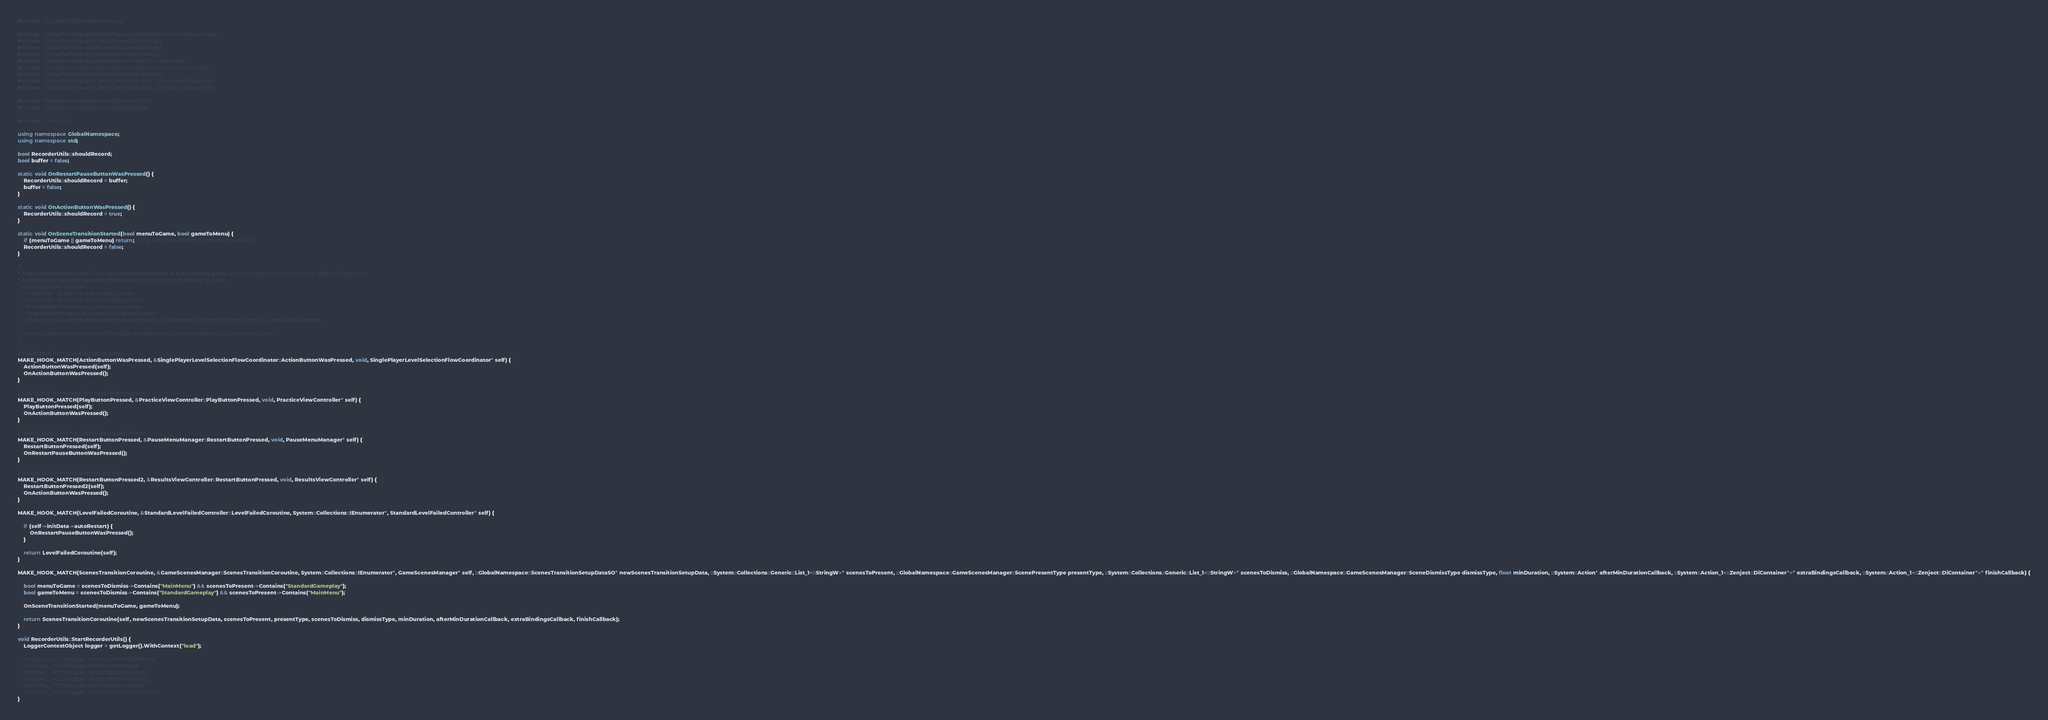Convert code to text. <code><loc_0><loc_0><loc_500><loc_500><_C++_>
#include "include/Utils/RecorderUtils.hpp"

#include "GlobalNamespace/SinglePlayerLevelSelectionFlowCoordinator.hpp"
#include "GlobalNamespace/PracticeViewController.hpp"
#include "GlobalNamespace/PauseMenuManager.hpp"
#include "GlobalNamespace/ResultsViewController.hpp"
#include "GlobalNamespace/StandardLevelFailedController.hpp"
#include "GlobalNamespace/StandardLevelFailedController_InitData.hpp"
#include "GlobalNamespace/GameScenesManager.hpp"
#include "GlobalNamespace/GameScenesManager_ScenePresentType.hpp"
#include "GlobalNamespace/GameScenesManager_SceneDismissType.hpp"

#include "beatsaber-hook/shared/utils/hooking.hpp"
#include "beatsaber-hook/shared/utils/logging.hpp"

#include "main.hpp"

using namespace GlobalNamespace;
using namespace std;

bool RecorderUtils::shouldRecord;
bool buffer = false;

static void OnRestartPauseButtonWasPressed() {
    RecorderUtils::shouldRecord = buffer;
    buffer = false;
}

static void OnActionButtonWasPressed() {
    RecorderUtils::shouldRecord = true;
}

static void OnSceneTransitionStarted(bool menuToGame, bool gameToMenu) {
    if (menuToGame || gameToMenu) return; // only transition related to Standard gameplay
    RecorderUtils::shouldRecord = false;
}

/*
* A set of patches that check if the user initiated a transition to the standard game scene through interaction with the default UI elements.
* All transitions beyond these are forbidden and will not trigger the replay recorder.
* Allowed flows for now are:
*  - Press 'Play'    button on a level select screen
*  - Press 'Play'    button on a practice setup screen
*  - Press 'Restart' button on a game pause sceen
*  - Press 'Restart' button on a level result details screen
*  - Failing a map with the enabled 'AutoRestart' option is considered as a restart button action in a game pause screen
*
*  This should prevent activation of the replay recorder for any unknown ways to run GameCore scene.
*/

// Play button from a level selection screen
MAKE_HOOK_MATCH(ActionButtonWasPressed, &SinglePlayerLevelSelectionFlowCoordinator::ActionButtonWasPressed, void, SinglePlayerLevelSelectionFlowCoordinator* self) {
    ActionButtonWasPressed(self);
    OnActionButtonWasPressed();
}

// Play button from a practice mode setting screen
MAKE_HOOK_MATCH(PlayButtonPressed, &PracticeViewController::PlayButtonPressed, void, PracticeViewController* self) {
    PlayButtonPressed(self);
    OnActionButtonWasPressed();
}

// Restart button from a GameCore paused screen
MAKE_HOOK_MATCH(RestartButtonPressed, &PauseMenuManager::RestartButtonPressed, void, PauseMenuManager* self) {
    RestartButtonPressed(self);
    OnRestartPauseButtonWasPressed();
}

// Restart button from a level result screen
MAKE_HOOK_MATCH(RestartButtonPressed2, &ResultsViewController::RestartButtonPressed, void, ResultsViewController* self) {
    RestartButtonPressed2(self);
    OnActionButtonWasPressed();
}

MAKE_HOOK_MATCH(LevelFailedCoroutine, &StandardLevelFailedController::LevelFailedCoroutine, System::Collections::IEnumerator*, StandardLevelFailedController* self) {
    
    if (self->initData->autoRestart) {
        OnRestartPauseButtonWasPressed();
    }

    return LevelFailedCoroutine(self);
}

MAKE_HOOK_MATCH(ScenesTransitionCoroutine, &GameScenesManager::ScenesTransitionCoroutine, System::Collections::IEnumerator*, GameScenesManager* self, ::GlobalNamespace::ScenesTransitionSetupDataSO* newScenesTransitionSetupData, ::System::Collections::Generic::List_1<::StringW>* scenesToPresent, ::GlobalNamespace::GameScenesManager::ScenePresentType presentType, ::System::Collections::Generic::List_1<::StringW>* scenesToDismiss, ::GlobalNamespace::GameScenesManager::SceneDismissType dismissType, float minDuration, ::System::Action* afterMinDurationCallback, ::System::Action_1<::Zenject::DiContainer*>* extraBindingsCallback, ::System::Action_1<::Zenject::DiContainer*>* finishCallback) {
    
    bool menuToGame = scenesToDismiss->Contains("MainMenu") && scenesToPresent->Contains("StandardGameplay");
    bool gameToMenu = scenesToDismiss->Contains("StandardGameplay") && scenesToPresent->Contains("MainMenu");

    OnSceneTransitionStarted(menuToGame, gameToMenu);

    return ScenesTransitionCoroutine(self, newScenesTransitionSetupData, scenesToPresent, presentType, scenesToDismiss, dismissType, minDuration, afterMinDurationCallback, extraBindingsCallback, finishCallback);
}

void RecorderUtils::StartRecorderUtils() {
    LoggerContextObject logger = getLogger().WithContext("load");

    // INSTALL_HOOK(logger, ActionButtonWasPressed);
    // INSTALL_HOOK(logger, PlayButtonPressed);
    // INSTALL_HOOK(logger, RestartButtonPressed);
    // INSTALL_HOOK(logger, RestartButtonPressed2);
    // INSTALL_HOOK(logger, LevelFailedCoroutine);
    // INSTALL_HOOK(logger, ScenesTransitionCoroutine);
}</code> 